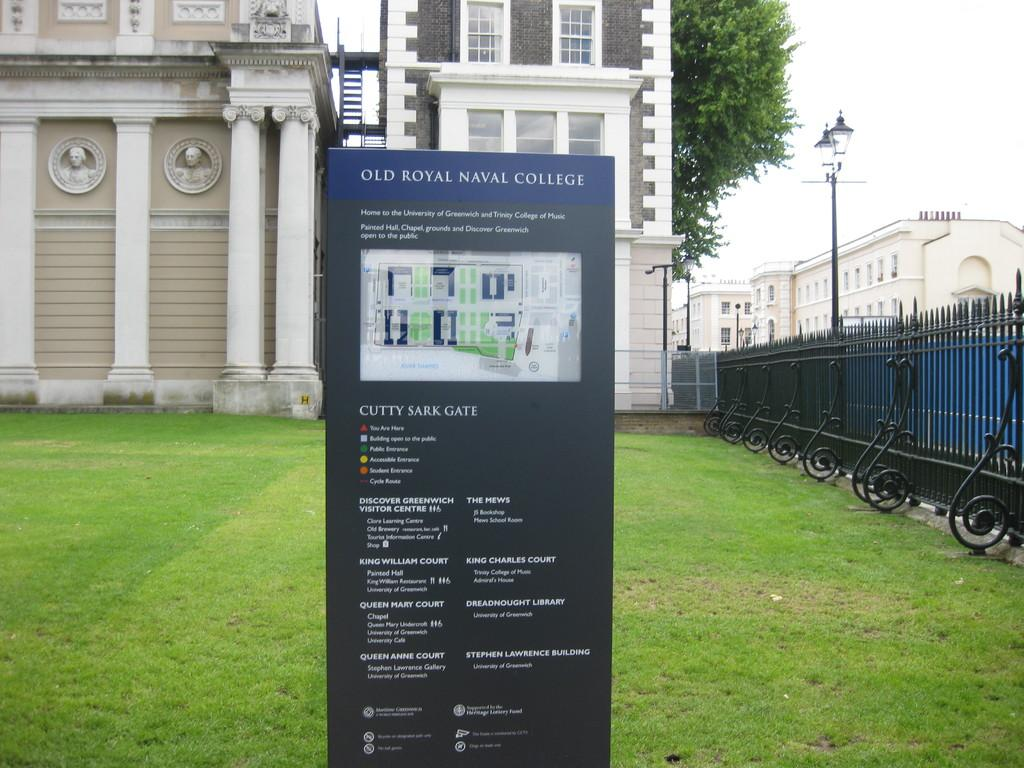What is the main object in the picture? There is a board in the picture. What type of natural environment is visible in the picture? There is grass in the picture. What can be seen on the right side of the picture? There is iron fencing on the right side of the picture. What is visible in the background of the picture? There are buildings, trees, and the sky in the background of the picture. What is the condition of the sky in the picture? The sky is clear and visible in the background of the picture. How many ladybugs can be seen crawling on the board in the picture? There are no ladybugs visible on the board in the picture. What type of bottle is present on the grass in the picture? There is no bottle present on the grass in the picture. 